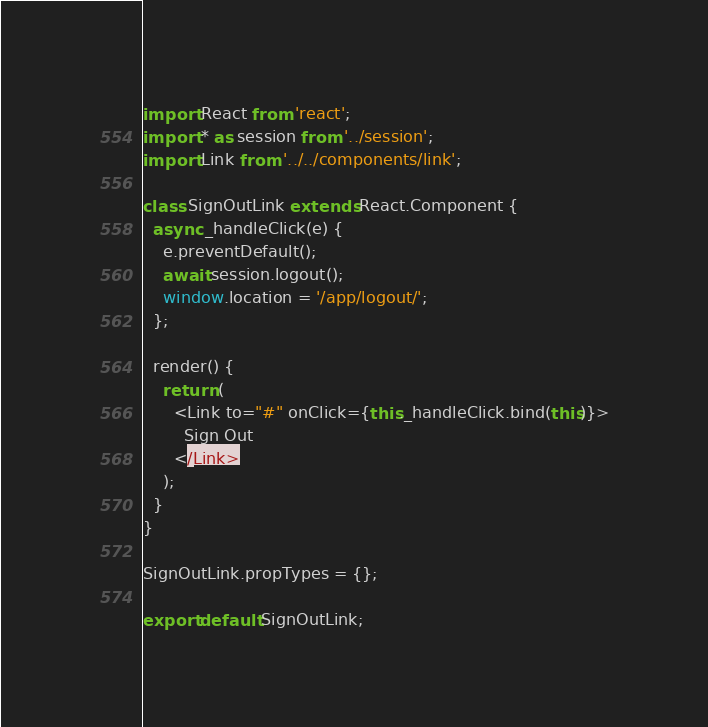<code> <loc_0><loc_0><loc_500><loc_500><_JavaScript_>import React from 'react';
import * as session from '../session';
import Link from '../../components/link';

class SignOutLink extends React.Component {
  async _handleClick(e) {
    e.preventDefault();
    await session.logout();
    window.location = '/app/logout/';
  };

  render() {
    return (
      <Link to="#" onClick={this._handleClick.bind(this)}>
        Sign Out
      </Link>
    );
  }
}

SignOutLink.propTypes = {};

export default SignOutLink;
</code> 